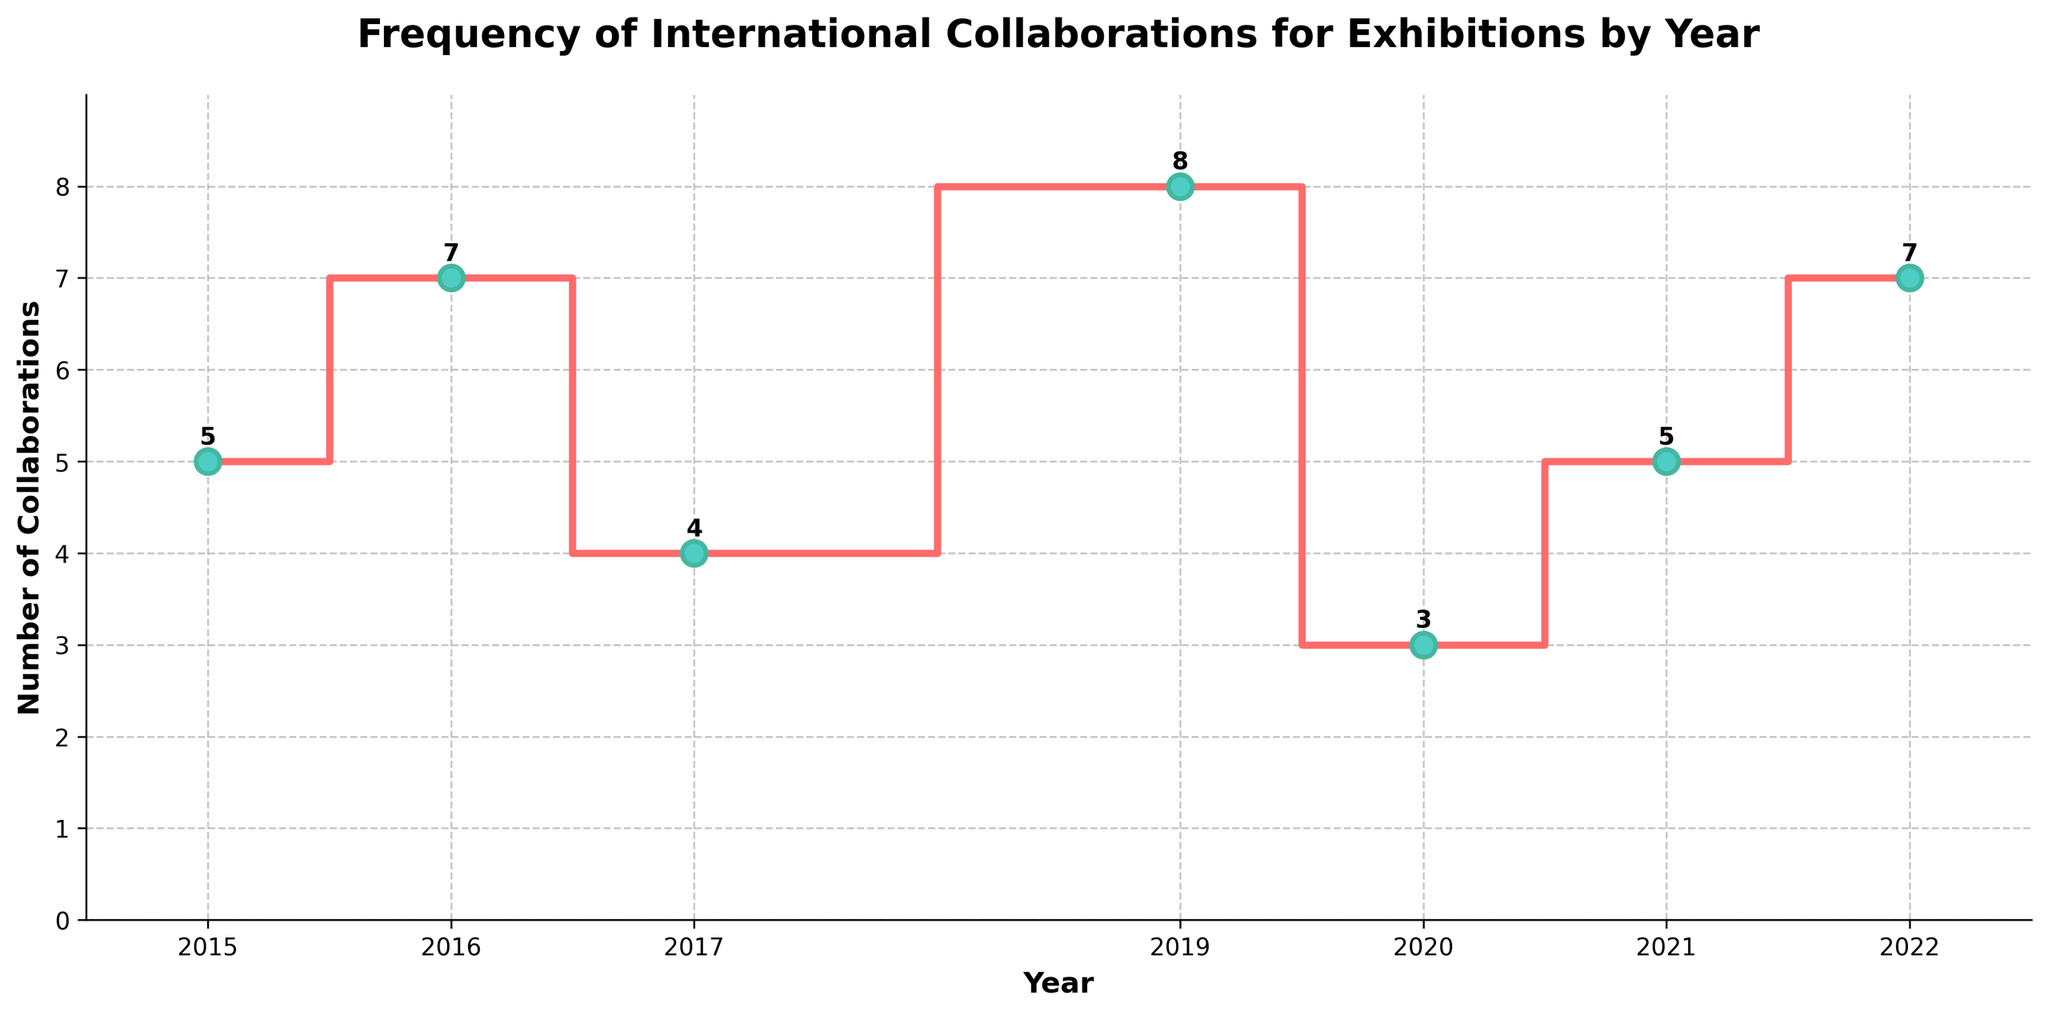What's the title of the plot? The title of the plot can be found at the top of the figure. It reads "Frequency of International Collaborations for Exhibitions by Year".
Answer: Frequency of International Collaborations for Exhibitions by Year Which year had the highest number of collaborations? The plot shows a peak at 2019 with 8 collaborations.
Answer: 2019 What were the number of collaborations in 2017? To find this, simply look at the point on the plot corresponding to the year 2017. The number given is 4.
Answer: 4 How many years had more than 5 collaborations? Identify points on the graph where the number of collaborations exceeds 5, which occurs in 2016, 2019, and 2022. So, there are 3 such years.
Answer: 3 What’s the average number of collaborations from 2015 to 2022? Sum the number of collaborations from each year (5 + 7 + 4 + 8 + 3 + 5 + 7) = 39, then divide by the number of years (7). The average number of collaborations is 39/7 ≈ 5.57.
Answer: ≈ 5.57 By how much did the number of collaborations change from 2016 to 2017? The collaborations dropped from 7 in 2016 to 4 in 2017. The change is 7 - 4 = 3.
Answer: 3 Compare 2020 and 2021, which year had more collaborations and by how much? 2020 had 3 collaborations and 2021 had 5 collaborations. The difference is 5 - 3 = 2.
Answer: 2021 by 2 Which year had the lowest number of collaborations and how many were there? The lowest collaboration number appears in 2020, with 3 collaborations.
Answer: 2020, 3 How did the number of collaborations change between 2019 and 2020? The number dropped from 8 in 2019 to 3 in 2020. The change is 8 - 3 = 5.
Answer: Decreased by 5 What is the total number of collaborations across all years shown? Add the collaborations for all the years: 5+7+4+8+3+5+7 = 39.
Answer: 39 